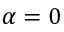<formula> <loc_0><loc_0><loc_500><loc_500>\alpha = 0</formula> 